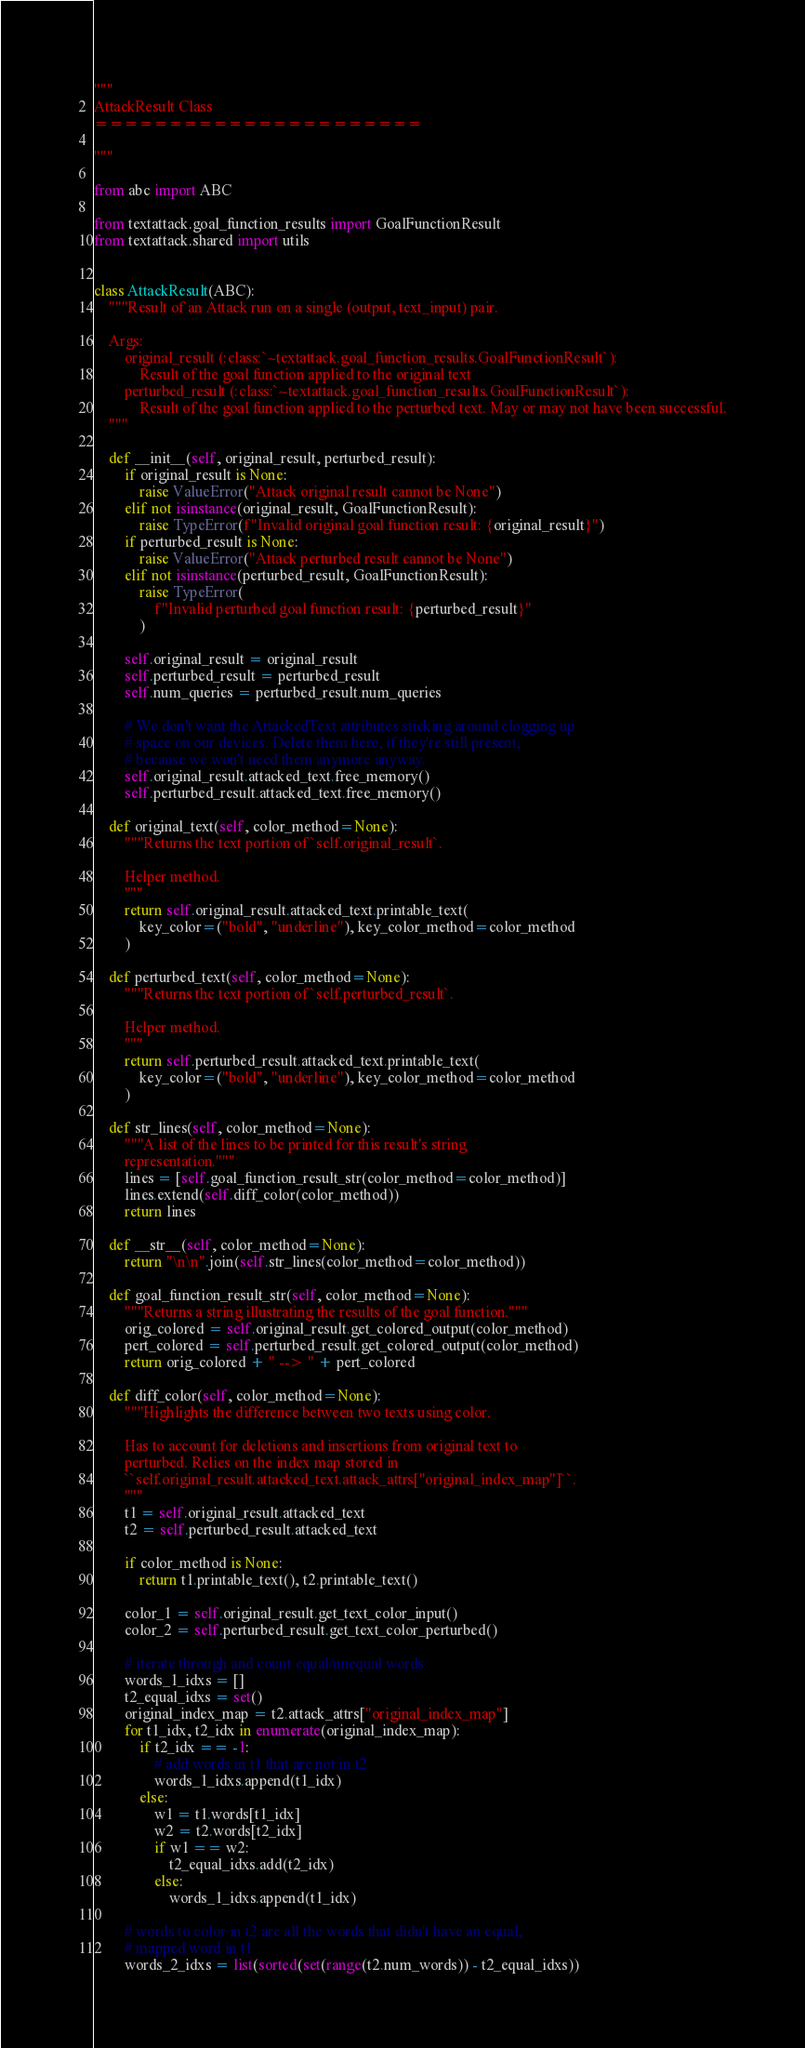<code> <loc_0><loc_0><loc_500><loc_500><_Python_>"""
AttackResult Class
======================

"""

from abc import ABC

from textattack.goal_function_results import GoalFunctionResult
from textattack.shared import utils


class AttackResult(ABC):
    """Result of an Attack run on a single (output, text_input) pair.

    Args:
        original_result (:class:`~textattack.goal_function_results.GoalFunctionResult`):
            Result of the goal function applied to the original text
        perturbed_result (:class:`~textattack.goal_function_results.GoalFunctionResult`):
            Result of the goal function applied to the perturbed text. May or may not have been successful.
    """

    def __init__(self, original_result, perturbed_result):
        if original_result is None:
            raise ValueError("Attack original result cannot be None")
        elif not isinstance(original_result, GoalFunctionResult):
            raise TypeError(f"Invalid original goal function result: {original_result}")
        if perturbed_result is None:
            raise ValueError("Attack perturbed result cannot be None")
        elif not isinstance(perturbed_result, GoalFunctionResult):
            raise TypeError(
                f"Invalid perturbed goal function result: {perturbed_result}"
            )

        self.original_result = original_result
        self.perturbed_result = perturbed_result
        self.num_queries = perturbed_result.num_queries

        # We don't want the AttackedText attributes sticking around clogging up
        # space on our devices. Delete them here, if they're still present,
        # because we won't need them anymore anyway.
        self.original_result.attacked_text.free_memory()
        self.perturbed_result.attacked_text.free_memory()

    def original_text(self, color_method=None):
        """Returns the text portion of `self.original_result`.

        Helper method.
        """
        return self.original_result.attacked_text.printable_text(
            key_color=("bold", "underline"), key_color_method=color_method
        )

    def perturbed_text(self, color_method=None):
        """Returns the text portion of `self.perturbed_result`.

        Helper method.
        """
        return self.perturbed_result.attacked_text.printable_text(
            key_color=("bold", "underline"), key_color_method=color_method
        )

    def str_lines(self, color_method=None):
        """A list of the lines to be printed for this result's string
        representation."""
        lines = [self.goal_function_result_str(color_method=color_method)]
        lines.extend(self.diff_color(color_method))
        return lines

    def __str__(self, color_method=None):
        return "\n\n".join(self.str_lines(color_method=color_method))

    def goal_function_result_str(self, color_method=None):
        """Returns a string illustrating the results of the goal function."""
        orig_colored = self.original_result.get_colored_output(color_method)
        pert_colored = self.perturbed_result.get_colored_output(color_method)
        return orig_colored + " --> " + pert_colored

    def diff_color(self, color_method=None):
        """Highlights the difference between two texts using color.

        Has to account for deletions and insertions from original text to
        perturbed. Relies on the index map stored in
        ``self.original_result.attacked_text.attack_attrs["original_index_map"]``.
        """
        t1 = self.original_result.attacked_text
        t2 = self.perturbed_result.attacked_text

        if color_method is None:
            return t1.printable_text(), t2.printable_text()

        color_1 = self.original_result.get_text_color_input()
        color_2 = self.perturbed_result.get_text_color_perturbed()

        # iterate through and count equal/unequal words
        words_1_idxs = []
        t2_equal_idxs = set()
        original_index_map = t2.attack_attrs["original_index_map"]
        for t1_idx, t2_idx in enumerate(original_index_map):
            if t2_idx == -1:
                # add words in t1 that are not in t2
                words_1_idxs.append(t1_idx)
            else:
                w1 = t1.words[t1_idx]
                w2 = t2.words[t2_idx]
                if w1 == w2:
                    t2_equal_idxs.add(t2_idx)
                else:
                    words_1_idxs.append(t1_idx)

        # words to color in t2 are all the words that didn't have an equal,
        # mapped word in t1
        words_2_idxs = list(sorted(set(range(t2.num_words)) - t2_equal_idxs))
</code> 